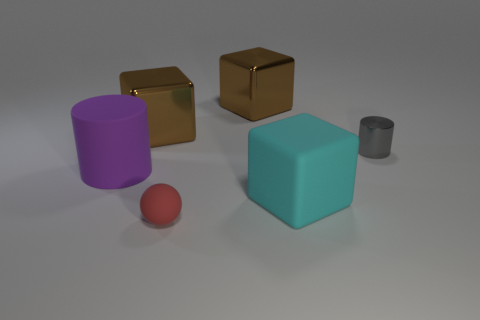Subtract all cyan cubes. How many cubes are left? 2 Subtract all brown metal blocks. How many blocks are left? 1 Subtract 1 cubes. How many cubes are left? 2 Subtract 0 purple spheres. How many objects are left? 6 Subtract all cylinders. How many objects are left? 4 Subtract all red blocks. Subtract all purple spheres. How many blocks are left? 3 Subtract all brown blocks. How many yellow spheres are left? 0 Subtract all gray metal things. Subtract all big metal blocks. How many objects are left? 3 Add 1 purple matte things. How many purple matte things are left? 2 Add 2 big brown objects. How many big brown objects exist? 4 